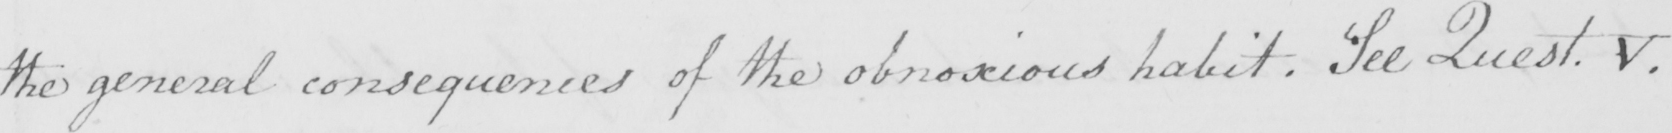What does this handwritten line say? the general consequences of the obnoxious habit . See Quest V . 